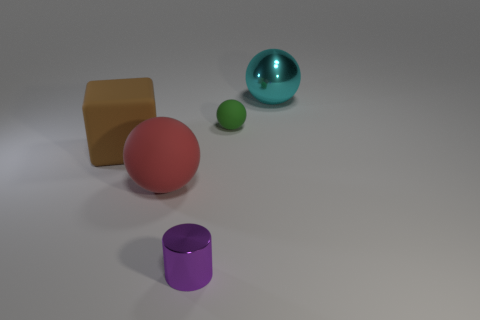Add 3 big brown cylinders. How many objects exist? 8 Subtract all blocks. How many objects are left? 4 Subtract 0 blue spheres. How many objects are left? 5 Subtract all tiny blue matte things. Subtract all small purple metallic objects. How many objects are left? 4 Add 3 cyan things. How many cyan things are left? 4 Add 1 tiny blue matte spheres. How many tiny blue matte spheres exist? 1 